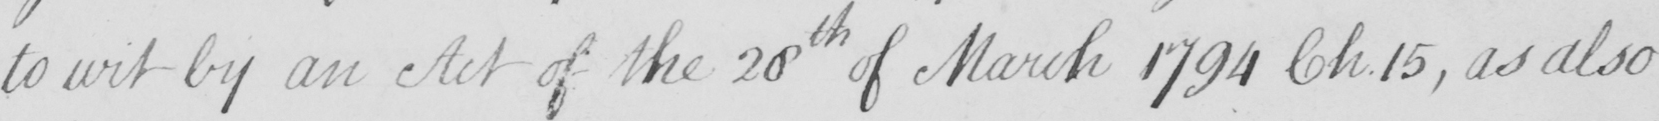Please transcribe the handwritten text in this image. to wit by an Act of the 28th of March 1794 Ch.15 , as also 